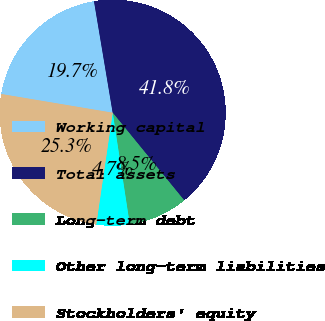Convert chart. <chart><loc_0><loc_0><loc_500><loc_500><pie_chart><fcel>Working capital<fcel>Total assets<fcel>Long-term debt<fcel>Other long-term liabilities<fcel>Stockholders' equity<nl><fcel>19.71%<fcel>41.75%<fcel>8.48%<fcel>4.74%<fcel>25.32%<nl></chart> 